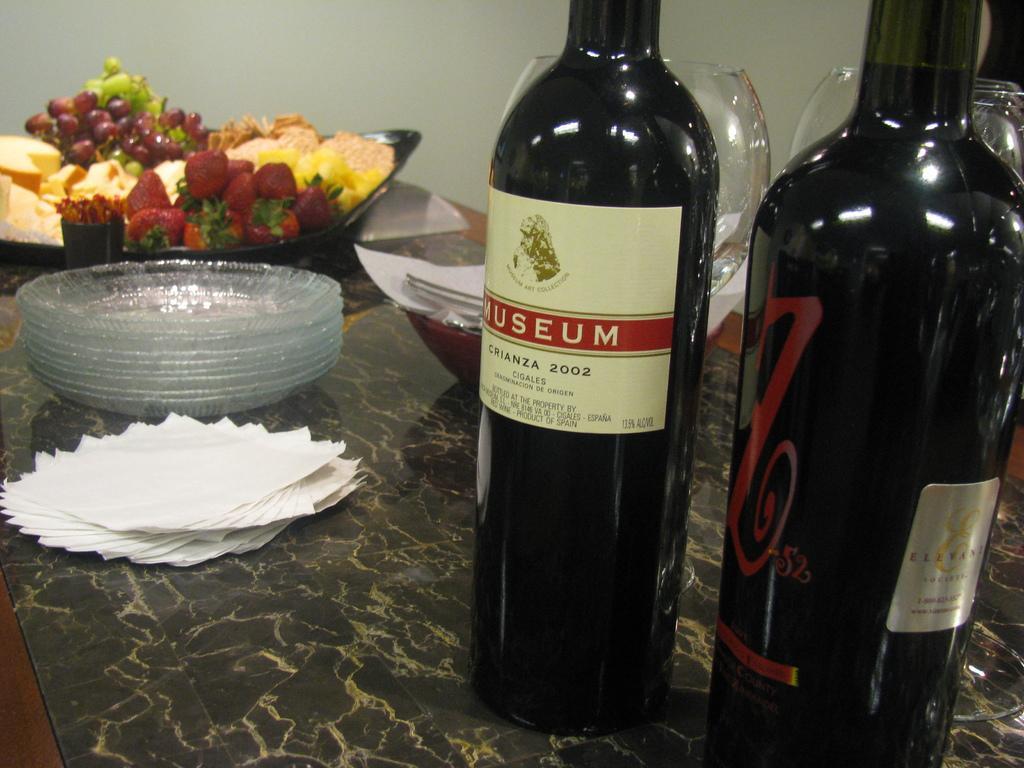How would you summarize this image in a sentence or two? In the image we can see there is table on which there are two wine bottles and wine glasses. There are plates, tissue papers and in a bowl there are food items. 